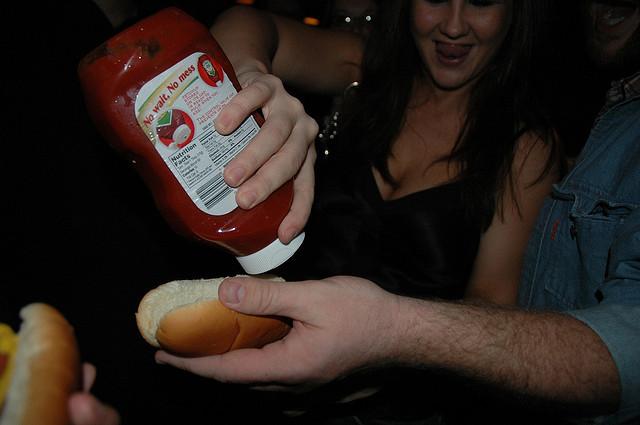Is there a lot of detail in this picture?
Keep it brief. No. What is in the bottle?
Quick response, please. Ketchup. What is the message attached to?
Give a very brief answer. Bottle. What is the woman holding?
Short answer required. Ketchup. What letters are on the object being held?
Answer briefly. No wait no mess. How many fingers are visible in this picture?
Keep it brief. 7. Is this the person wearing a silver ring?
Write a very short answer. No. Do you have short sexy hair?
Give a very brief answer. No. What is she pouring?
Be succinct. Ketchup. What is this person holding?
Answer briefly. Ketchup. What meat goes in this bun?
Short answer required. Hot dog. What is the device used for?
Quick response, please. Pouring ketchup. What is in the man's hand?
Concise answer only. Ketchup. Is the man enjoying his hot dog?
Quick response, please. Yes. Is there any ketchup on the hot dog?
Give a very brief answer. No. Which item is in the middle?
Quick response, please. Ketchup. 